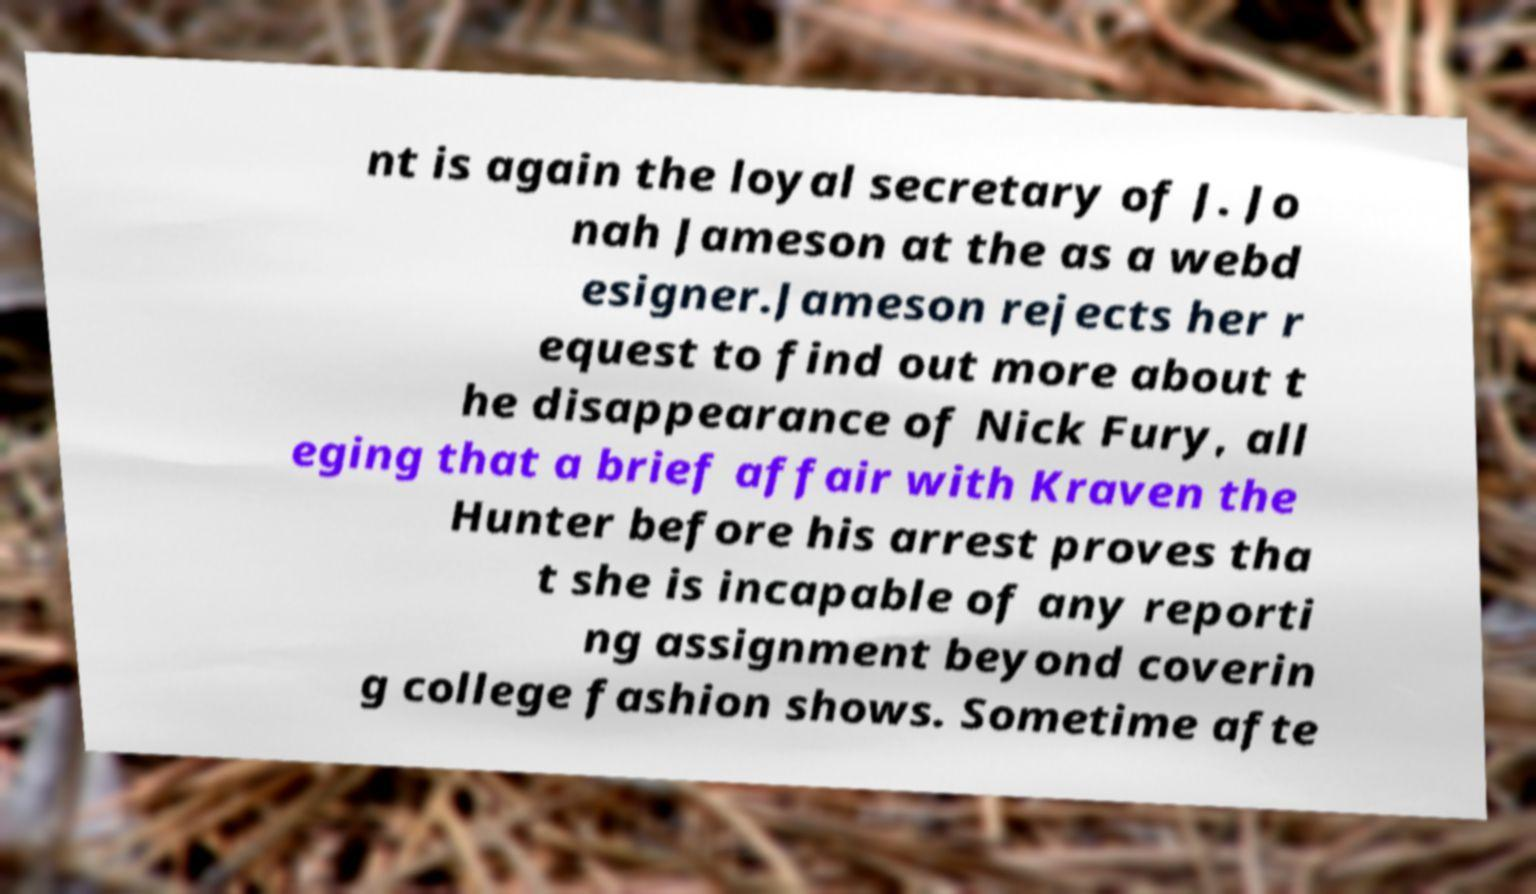There's text embedded in this image that I need extracted. Can you transcribe it verbatim? nt is again the loyal secretary of J. Jo nah Jameson at the as a webd esigner.Jameson rejects her r equest to find out more about t he disappearance of Nick Fury, all eging that a brief affair with Kraven the Hunter before his arrest proves tha t she is incapable of any reporti ng assignment beyond coverin g college fashion shows. Sometime afte 